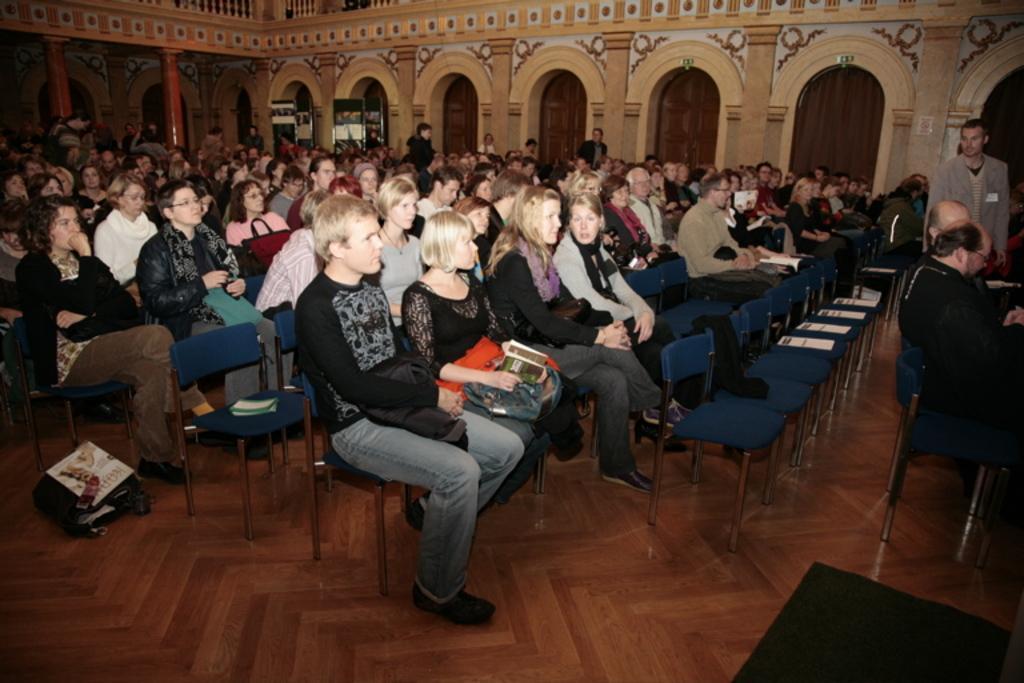Describe this image in one or two sentences. In this image I can see the group of people sitting on the chairs and some people are standing. One woman is holding someone is holding some objects with her. On the floor there is a bag and books. 